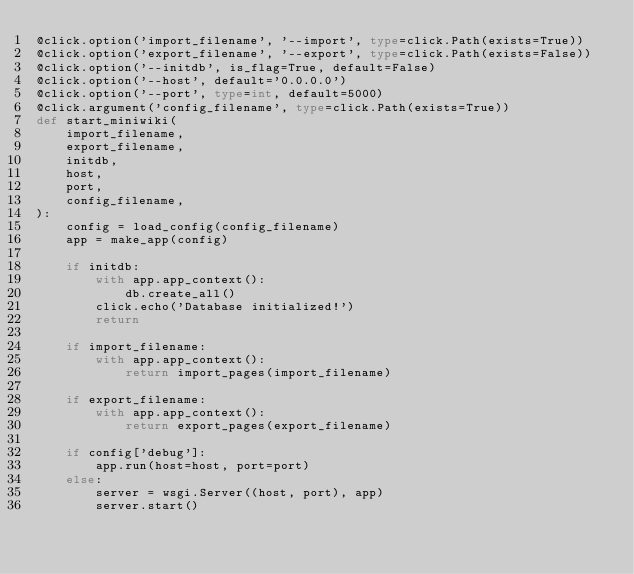Convert code to text. <code><loc_0><loc_0><loc_500><loc_500><_Python_>@click.option('import_filename', '--import', type=click.Path(exists=True))
@click.option('export_filename', '--export', type=click.Path(exists=False))
@click.option('--initdb', is_flag=True, default=False)
@click.option('--host', default='0.0.0.0')
@click.option('--port', type=int, default=5000)
@click.argument('config_filename', type=click.Path(exists=True))
def start_miniwiki(
    import_filename,
    export_filename,
    initdb,
    host,
    port,
    config_filename,
):
    config = load_config(config_filename)
    app = make_app(config)

    if initdb:
        with app.app_context():
            db.create_all()
        click.echo('Database initialized!')
        return

    if import_filename:
        with app.app_context():
            return import_pages(import_filename)

    if export_filename:
        with app.app_context():
            return export_pages(export_filename)

    if config['debug']:
        app.run(host=host, port=port)
    else:
        server = wsgi.Server((host, port), app)
        server.start()
</code> 